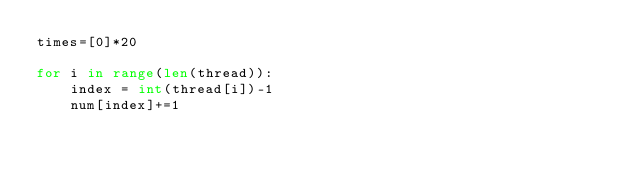Convert code to text. <code><loc_0><loc_0><loc_500><loc_500><_Python_>times=[0]*20

for i in range(len(thread)):
    index = int(thread[i])-1
    num[index]+=1</code> 